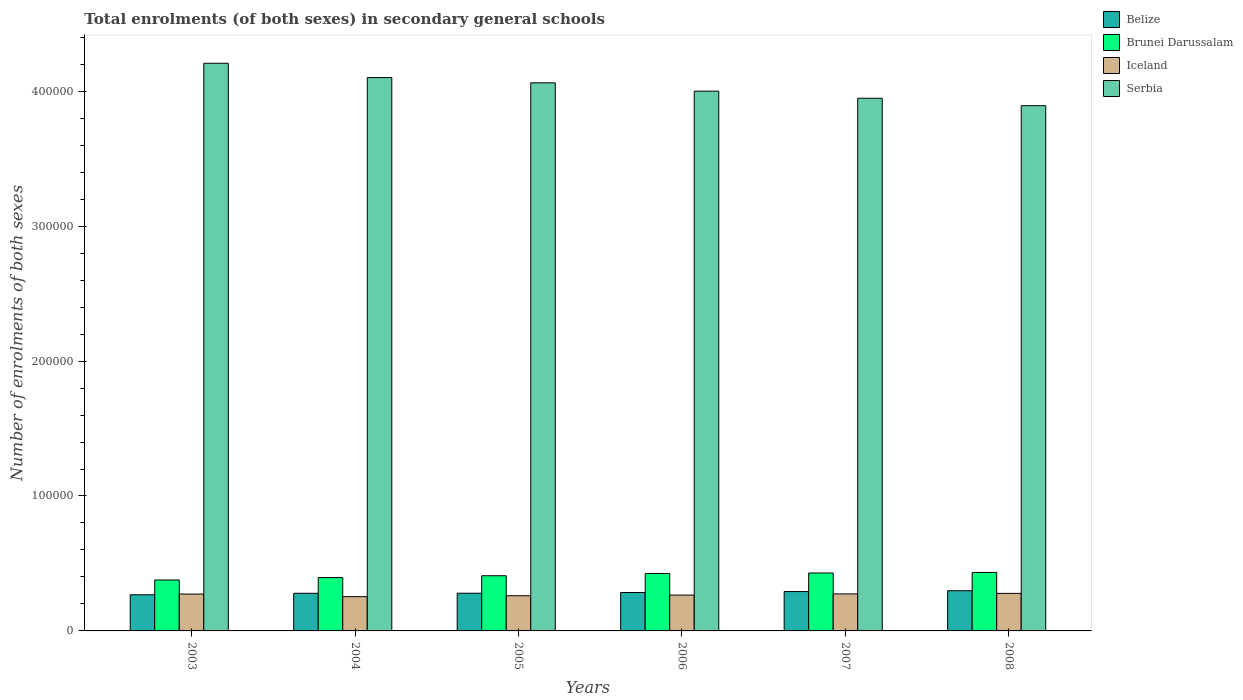How many different coloured bars are there?
Your answer should be compact. 4. How many groups of bars are there?
Your response must be concise. 6. Are the number of bars per tick equal to the number of legend labels?
Provide a succinct answer. Yes. Are the number of bars on each tick of the X-axis equal?
Offer a very short reply. Yes. How many bars are there on the 6th tick from the right?
Provide a short and direct response. 4. What is the label of the 4th group of bars from the left?
Your response must be concise. 2006. In how many cases, is the number of bars for a given year not equal to the number of legend labels?
Provide a short and direct response. 0. What is the number of enrolments in secondary schools in Iceland in 2006?
Give a very brief answer. 2.66e+04. Across all years, what is the maximum number of enrolments in secondary schools in Serbia?
Your response must be concise. 4.21e+05. Across all years, what is the minimum number of enrolments in secondary schools in Iceland?
Your answer should be compact. 2.54e+04. What is the total number of enrolments in secondary schools in Iceland in the graph?
Your response must be concise. 1.61e+05. What is the difference between the number of enrolments in secondary schools in Iceland in 2003 and that in 2005?
Ensure brevity in your answer.  1239. What is the difference between the number of enrolments in secondary schools in Brunei Darussalam in 2008 and the number of enrolments in secondary schools in Belize in 2004?
Offer a very short reply. 1.54e+04. What is the average number of enrolments in secondary schools in Belize per year?
Offer a terse response. 2.83e+04. In the year 2008, what is the difference between the number of enrolments in secondary schools in Serbia and number of enrolments in secondary schools in Belize?
Make the answer very short. 3.59e+05. In how many years, is the number of enrolments in secondary schools in Brunei Darussalam greater than 200000?
Give a very brief answer. 0. What is the ratio of the number of enrolments in secondary schools in Belize in 2005 to that in 2006?
Your answer should be compact. 0.98. Is the difference between the number of enrolments in secondary schools in Serbia in 2005 and 2007 greater than the difference between the number of enrolments in secondary schools in Belize in 2005 and 2007?
Keep it short and to the point. Yes. What is the difference between the highest and the second highest number of enrolments in secondary schools in Belize?
Offer a terse response. 625. What is the difference between the highest and the lowest number of enrolments in secondary schools in Iceland?
Keep it short and to the point. 2421. Is the sum of the number of enrolments in secondary schools in Iceland in 2004 and 2005 greater than the maximum number of enrolments in secondary schools in Serbia across all years?
Your answer should be very brief. No. Is it the case that in every year, the sum of the number of enrolments in secondary schools in Brunei Darussalam and number of enrolments in secondary schools in Serbia is greater than the sum of number of enrolments in secondary schools in Belize and number of enrolments in secondary schools in Iceland?
Keep it short and to the point. Yes. What does the 4th bar from the left in 2008 represents?
Offer a very short reply. Serbia. What does the 4th bar from the right in 2004 represents?
Provide a short and direct response. Belize. How many years are there in the graph?
Your response must be concise. 6. Are the values on the major ticks of Y-axis written in scientific E-notation?
Offer a terse response. No. Where does the legend appear in the graph?
Give a very brief answer. Top right. How many legend labels are there?
Your answer should be compact. 4. How are the legend labels stacked?
Provide a succinct answer. Vertical. What is the title of the graph?
Your response must be concise. Total enrolments (of both sexes) in secondary general schools. Does "Brazil" appear as one of the legend labels in the graph?
Your response must be concise. No. What is the label or title of the X-axis?
Give a very brief answer. Years. What is the label or title of the Y-axis?
Give a very brief answer. Number of enrolments of both sexes. What is the Number of enrolments of both sexes of Belize in 2003?
Provide a succinct answer. 2.68e+04. What is the Number of enrolments of both sexes of Brunei Darussalam in 2003?
Provide a succinct answer. 3.77e+04. What is the Number of enrolments of both sexes in Iceland in 2003?
Offer a very short reply. 2.73e+04. What is the Number of enrolments of both sexes of Serbia in 2003?
Provide a short and direct response. 4.21e+05. What is the Number of enrolments of both sexes in Belize in 2004?
Provide a succinct answer. 2.79e+04. What is the Number of enrolments of both sexes of Brunei Darussalam in 2004?
Make the answer very short. 3.96e+04. What is the Number of enrolments of both sexes of Iceland in 2004?
Give a very brief answer. 2.54e+04. What is the Number of enrolments of both sexes of Serbia in 2004?
Keep it short and to the point. 4.10e+05. What is the Number of enrolments of both sexes of Belize in 2005?
Make the answer very short. 2.79e+04. What is the Number of enrolments of both sexes in Brunei Darussalam in 2005?
Your response must be concise. 4.09e+04. What is the Number of enrolments of both sexes of Iceland in 2005?
Give a very brief answer. 2.61e+04. What is the Number of enrolments of both sexes in Serbia in 2005?
Offer a very short reply. 4.06e+05. What is the Number of enrolments of both sexes in Belize in 2006?
Offer a very short reply. 2.85e+04. What is the Number of enrolments of both sexes in Brunei Darussalam in 2006?
Offer a very short reply. 4.26e+04. What is the Number of enrolments of both sexes in Iceland in 2006?
Your answer should be very brief. 2.66e+04. What is the Number of enrolments of both sexes in Serbia in 2006?
Provide a succinct answer. 4.00e+05. What is the Number of enrolments of both sexes in Belize in 2007?
Ensure brevity in your answer.  2.92e+04. What is the Number of enrolments of both sexes in Brunei Darussalam in 2007?
Your response must be concise. 4.29e+04. What is the Number of enrolments of both sexes in Iceland in 2007?
Offer a terse response. 2.74e+04. What is the Number of enrolments of both sexes of Serbia in 2007?
Your answer should be compact. 3.95e+05. What is the Number of enrolments of both sexes of Belize in 2008?
Your answer should be very brief. 2.98e+04. What is the Number of enrolments of both sexes of Brunei Darussalam in 2008?
Offer a terse response. 4.33e+04. What is the Number of enrolments of both sexes in Iceland in 2008?
Offer a terse response. 2.78e+04. What is the Number of enrolments of both sexes in Serbia in 2008?
Your response must be concise. 3.89e+05. Across all years, what is the maximum Number of enrolments of both sexes in Belize?
Offer a very short reply. 2.98e+04. Across all years, what is the maximum Number of enrolments of both sexes in Brunei Darussalam?
Offer a very short reply. 4.33e+04. Across all years, what is the maximum Number of enrolments of both sexes in Iceland?
Ensure brevity in your answer.  2.78e+04. Across all years, what is the maximum Number of enrolments of both sexes in Serbia?
Offer a terse response. 4.21e+05. Across all years, what is the minimum Number of enrolments of both sexes in Belize?
Your answer should be compact. 2.68e+04. Across all years, what is the minimum Number of enrolments of both sexes of Brunei Darussalam?
Provide a short and direct response. 3.77e+04. Across all years, what is the minimum Number of enrolments of both sexes in Iceland?
Provide a short and direct response. 2.54e+04. Across all years, what is the minimum Number of enrolments of both sexes of Serbia?
Provide a succinct answer. 3.89e+05. What is the total Number of enrolments of both sexes of Belize in the graph?
Provide a succinct answer. 1.70e+05. What is the total Number of enrolments of both sexes in Brunei Darussalam in the graph?
Make the answer very short. 2.47e+05. What is the total Number of enrolments of both sexes of Iceland in the graph?
Ensure brevity in your answer.  1.61e+05. What is the total Number of enrolments of both sexes of Serbia in the graph?
Provide a succinct answer. 2.42e+06. What is the difference between the Number of enrolments of both sexes of Belize in 2003 and that in 2004?
Your answer should be very brief. -1094. What is the difference between the Number of enrolments of both sexes in Brunei Darussalam in 2003 and that in 2004?
Your answer should be very brief. -1810. What is the difference between the Number of enrolments of both sexes of Iceland in 2003 and that in 2004?
Your answer should be compact. 1921. What is the difference between the Number of enrolments of both sexes of Serbia in 2003 and that in 2004?
Give a very brief answer. 1.06e+04. What is the difference between the Number of enrolments of both sexes of Belize in 2003 and that in 2005?
Your answer should be very brief. -1115. What is the difference between the Number of enrolments of both sexes of Brunei Darussalam in 2003 and that in 2005?
Provide a succinct answer. -3147. What is the difference between the Number of enrolments of both sexes in Iceland in 2003 and that in 2005?
Provide a short and direct response. 1239. What is the difference between the Number of enrolments of both sexes in Serbia in 2003 and that in 2005?
Give a very brief answer. 1.45e+04. What is the difference between the Number of enrolments of both sexes in Belize in 2003 and that in 2006?
Provide a succinct answer. -1650. What is the difference between the Number of enrolments of both sexes of Brunei Darussalam in 2003 and that in 2006?
Your response must be concise. -4855. What is the difference between the Number of enrolments of both sexes in Iceland in 2003 and that in 2006?
Your response must be concise. 761. What is the difference between the Number of enrolments of both sexes of Serbia in 2003 and that in 2006?
Give a very brief answer. 2.07e+04. What is the difference between the Number of enrolments of both sexes in Belize in 2003 and that in 2007?
Provide a short and direct response. -2372. What is the difference between the Number of enrolments of both sexes in Brunei Darussalam in 2003 and that in 2007?
Offer a terse response. -5200. What is the difference between the Number of enrolments of both sexes in Iceland in 2003 and that in 2007?
Your answer should be compact. -112. What is the difference between the Number of enrolments of both sexes of Serbia in 2003 and that in 2007?
Offer a very short reply. 2.59e+04. What is the difference between the Number of enrolments of both sexes of Belize in 2003 and that in 2008?
Ensure brevity in your answer.  -2997. What is the difference between the Number of enrolments of both sexes of Brunei Darussalam in 2003 and that in 2008?
Offer a very short reply. -5602. What is the difference between the Number of enrolments of both sexes of Iceland in 2003 and that in 2008?
Keep it short and to the point. -500. What is the difference between the Number of enrolments of both sexes in Serbia in 2003 and that in 2008?
Your response must be concise. 3.14e+04. What is the difference between the Number of enrolments of both sexes in Belize in 2004 and that in 2005?
Ensure brevity in your answer.  -21. What is the difference between the Number of enrolments of both sexes of Brunei Darussalam in 2004 and that in 2005?
Give a very brief answer. -1337. What is the difference between the Number of enrolments of both sexes in Iceland in 2004 and that in 2005?
Keep it short and to the point. -682. What is the difference between the Number of enrolments of both sexes in Serbia in 2004 and that in 2005?
Provide a short and direct response. 3877. What is the difference between the Number of enrolments of both sexes in Belize in 2004 and that in 2006?
Offer a very short reply. -556. What is the difference between the Number of enrolments of both sexes in Brunei Darussalam in 2004 and that in 2006?
Keep it short and to the point. -3045. What is the difference between the Number of enrolments of both sexes in Iceland in 2004 and that in 2006?
Offer a very short reply. -1160. What is the difference between the Number of enrolments of both sexes of Serbia in 2004 and that in 2006?
Give a very brief answer. 1.01e+04. What is the difference between the Number of enrolments of both sexes in Belize in 2004 and that in 2007?
Keep it short and to the point. -1278. What is the difference between the Number of enrolments of both sexes of Brunei Darussalam in 2004 and that in 2007?
Provide a short and direct response. -3390. What is the difference between the Number of enrolments of both sexes in Iceland in 2004 and that in 2007?
Your answer should be compact. -2033. What is the difference between the Number of enrolments of both sexes in Serbia in 2004 and that in 2007?
Keep it short and to the point. 1.53e+04. What is the difference between the Number of enrolments of both sexes of Belize in 2004 and that in 2008?
Provide a succinct answer. -1903. What is the difference between the Number of enrolments of both sexes of Brunei Darussalam in 2004 and that in 2008?
Your response must be concise. -3792. What is the difference between the Number of enrolments of both sexes in Iceland in 2004 and that in 2008?
Make the answer very short. -2421. What is the difference between the Number of enrolments of both sexes of Serbia in 2004 and that in 2008?
Your answer should be compact. 2.08e+04. What is the difference between the Number of enrolments of both sexes of Belize in 2005 and that in 2006?
Give a very brief answer. -535. What is the difference between the Number of enrolments of both sexes of Brunei Darussalam in 2005 and that in 2006?
Make the answer very short. -1708. What is the difference between the Number of enrolments of both sexes in Iceland in 2005 and that in 2006?
Your answer should be very brief. -478. What is the difference between the Number of enrolments of both sexes of Serbia in 2005 and that in 2006?
Your response must be concise. 6180. What is the difference between the Number of enrolments of both sexes in Belize in 2005 and that in 2007?
Your answer should be very brief. -1257. What is the difference between the Number of enrolments of both sexes in Brunei Darussalam in 2005 and that in 2007?
Provide a short and direct response. -2053. What is the difference between the Number of enrolments of both sexes of Iceland in 2005 and that in 2007?
Provide a succinct answer. -1351. What is the difference between the Number of enrolments of both sexes in Serbia in 2005 and that in 2007?
Your answer should be very brief. 1.14e+04. What is the difference between the Number of enrolments of both sexes of Belize in 2005 and that in 2008?
Your answer should be compact. -1882. What is the difference between the Number of enrolments of both sexes of Brunei Darussalam in 2005 and that in 2008?
Your answer should be compact. -2455. What is the difference between the Number of enrolments of both sexes of Iceland in 2005 and that in 2008?
Your answer should be compact. -1739. What is the difference between the Number of enrolments of both sexes in Serbia in 2005 and that in 2008?
Your answer should be very brief. 1.70e+04. What is the difference between the Number of enrolments of both sexes of Belize in 2006 and that in 2007?
Your answer should be very brief. -722. What is the difference between the Number of enrolments of both sexes of Brunei Darussalam in 2006 and that in 2007?
Give a very brief answer. -345. What is the difference between the Number of enrolments of both sexes in Iceland in 2006 and that in 2007?
Provide a short and direct response. -873. What is the difference between the Number of enrolments of both sexes of Serbia in 2006 and that in 2007?
Keep it short and to the point. 5261. What is the difference between the Number of enrolments of both sexes in Belize in 2006 and that in 2008?
Offer a terse response. -1347. What is the difference between the Number of enrolments of both sexes of Brunei Darussalam in 2006 and that in 2008?
Your answer should be compact. -747. What is the difference between the Number of enrolments of both sexes of Iceland in 2006 and that in 2008?
Provide a short and direct response. -1261. What is the difference between the Number of enrolments of both sexes in Serbia in 2006 and that in 2008?
Offer a very short reply. 1.08e+04. What is the difference between the Number of enrolments of both sexes of Belize in 2007 and that in 2008?
Provide a short and direct response. -625. What is the difference between the Number of enrolments of both sexes in Brunei Darussalam in 2007 and that in 2008?
Your answer should be compact. -402. What is the difference between the Number of enrolments of both sexes of Iceland in 2007 and that in 2008?
Keep it short and to the point. -388. What is the difference between the Number of enrolments of both sexes in Serbia in 2007 and that in 2008?
Give a very brief answer. 5512. What is the difference between the Number of enrolments of both sexes in Belize in 2003 and the Number of enrolments of both sexes in Brunei Darussalam in 2004?
Keep it short and to the point. -1.27e+04. What is the difference between the Number of enrolments of both sexes in Belize in 2003 and the Number of enrolments of both sexes in Iceland in 2004?
Keep it short and to the point. 1410. What is the difference between the Number of enrolments of both sexes of Belize in 2003 and the Number of enrolments of both sexes of Serbia in 2004?
Offer a terse response. -3.83e+05. What is the difference between the Number of enrolments of both sexes of Brunei Darussalam in 2003 and the Number of enrolments of both sexes of Iceland in 2004?
Keep it short and to the point. 1.23e+04. What is the difference between the Number of enrolments of both sexes of Brunei Darussalam in 2003 and the Number of enrolments of both sexes of Serbia in 2004?
Your answer should be compact. -3.72e+05. What is the difference between the Number of enrolments of both sexes in Iceland in 2003 and the Number of enrolments of both sexes in Serbia in 2004?
Make the answer very short. -3.83e+05. What is the difference between the Number of enrolments of both sexes in Belize in 2003 and the Number of enrolments of both sexes in Brunei Darussalam in 2005?
Your answer should be compact. -1.41e+04. What is the difference between the Number of enrolments of both sexes in Belize in 2003 and the Number of enrolments of both sexes in Iceland in 2005?
Your response must be concise. 728. What is the difference between the Number of enrolments of both sexes in Belize in 2003 and the Number of enrolments of both sexes in Serbia in 2005?
Offer a terse response. -3.79e+05. What is the difference between the Number of enrolments of both sexes in Brunei Darussalam in 2003 and the Number of enrolments of both sexes in Iceland in 2005?
Offer a terse response. 1.17e+04. What is the difference between the Number of enrolments of both sexes of Brunei Darussalam in 2003 and the Number of enrolments of both sexes of Serbia in 2005?
Provide a short and direct response. -3.68e+05. What is the difference between the Number of enrolments of both sexes in Iceland in 2003 and the Number of enrolments of both sexes in Serbia in 2005?
Your answer should be compact. -3.79e+05. What is the difference between the Number of enrolments of both sexes in Belize in 2003 and the Number of enrolments of both sexes in Brunei Darussalam in 2006?
Your answer should be very brief. -1.58e+04. What is the difference between the Number of enrolments of both sexes of Belize in 2003 and the Number of enrolments of both sexes of Iceland in 2006?
Give a very brief answer. 250. What is the difference between the Number of enrolments of both sexes of Belize in 2003 and the Number of enrolments of both sexes of Serbia in 2006?
Ensure brevity in your answer.  -3.73e+05. What is the difference between the Number of enrolments of both sexes in Brunei Darussalam in 2003 and the Number of enrolments of both sexes in Iceland in 2006?
Offer a terse response. 1.12e+04. What is the difference between the Number of enrolments of both sexes in Brunei Darussalam in 2003 and the Number of enrolments of both sexes in Serbia in 2006?
Ensure brevity in your answer.  -3.62e+05. What is the difference between the Number of enrolments of both sexes in Iceland in 2003 and the Number of enrolments of both sexes in Serbia in 2006?
Keep it short and to the point. -3.73e+05. What is the difference between the Number of enrolments of both sexes of Belize in 2003 and the Number of enrolments of both sexes of Brunei Darussalam in 2007?
Your answer should be compact. -1.61e+04. What is the difference between the Number of enrolments of both sexes in Belize in 2003 and the Number of enrolments of both sexes in Iceland in 2007?
Give a very brief answer. -623. What is the difference between the Number of enrolments of both sexes of Belize in 2003 and the Number of enrolments of both sexes of Serbia in 2007?
Keep it short and to the point. -3.68e+05. What is the difference between the Number of enrolments of both sexes of Brunei Darussalam in 2003 and the Number of enrolments of both sexes of Iceland in 2007?
Your response must be concise. 1.03e+04. What is the difference between the Number of enrolments of both sexes in Brunei Darussalam in 2003 and the Number of enrolments of both sexes in Serbia in 2007?
Your answer should be compact. -3.57e+05. What is the difference between the Number of enrolments of both sexes of Iceland in 2003 and the Number of enrolments of both sexes of Serbia in 2007?
Keep it short and to the point. -3.67e+05. What is the difference between the Number of enrolments of both sexes in Belize in 2003 and the Number of enrolments of both sexes in Brunei Darussalam in 2008?
Provide a short and direct response. -1.65e+04. What is the difference between the Number of enrolments of both sexes of Belize in 2003 and the Number of enrolments of both sexes of Iceland in 2008?
Make the answer very short. -1011. What is the difference between the Number of enrolments of both sexes of Belize in 2003 and the Number of enrolments of both sexes of Serbia in 2008?
Your answer should be compact. -3.62e+05. What is the difference between the Number of enrolments of both sexes of Brunei Darussalam in 2003 and the Number of enrolments of both sexes of Iceland in 2008?
Offer a terse response. 9922. What is the difference between the Number of enrolments of both sexes of Brunei Darussalam in 2003 and the Number of enrolments of both sexes of Serbia in 2008?
Your response must be concise. -3.52e+05. What is the difference between the Number of enrolments of both sexes of Iceland in 2003 and the Number of enrolments of both sexes of Serbia in 2008?
Offer a terse response. -3.62e+05. What is the difference between the Number of enrolments of both sexes in Belize in 2004 and the Number of enrolments of both sexes in Brunei Darussalam in 2005?
Your answer should be compact. -1.30e+04. What is the difference between the Number of enrolments of both sexes of Belize in 2004 and the Number of enrolments of both sexes of Iceland in 2005?
Provide a short and direct response. 1822. What is the difference between the Number of enrolments of both sexes in Belize in 2004 and the Number of enrolments of both sexes in Serbia in 2005?
Provide a short and direct response. -3.78e+05. What is the difference between the Number of enrolments of both sexes of Brunei Darussalam in 2004 and the Number of enrolments of both sexes of Iceland in 2005?
Offer a terse response. 1.35e+04. What is the difference between the Number of enrolments of both sexes in Brunei Darussalam in 2004 and the Number of enrolments of both sexes in Serbia in 2005?
Keep it short and to the point. -3.67e+05. What is the difference between the Number of enrolments of both sexes in Iceland in 2004 and the Number of enrolments of both sexes in Serbia in 2005?
Your answer should be compact. -3.81e+05. What is the difference between the Number of enrolments of both sexes in Belize in 2004 and the Number of enrolments of both sexes in Brunei Darussalam in 2006?
Make the answer very short. -1.47e+04. What is the difference between the Number of enrolments of both sexes in Belize in 2004 and the Number of enrolments of both sexes in Iceland in 2006?
Your answer should be very brief. 1344. What is the difference between the Number of enrolments of both sexes in Belize in 2004 and the Number of enrolments of both sexes in Serbia in 2006?
Provide a short and direct response. -3.72e+05. What is the difference between the Number of enrolments of both sexes in Brunei Darussalam in 2004 and the Number of enrolments of both sexes in Iceland in 2006?
Your answer should be very brief. 1.30e+04. What is the difference between the Number of enrolments of both sexes in Brunei Darussalam in 2004 and the Number of enrolments of both sexes in Serbia in 2006?
Provide a short and direct response. -3.60e+05. What is the difference between the Number of enrolments of both sexes of Iceland in 2004 and the Number of enrolments of both sexes of Serbia in 2006?
Your answer should be compact. -3.75e+05. What is the difference between the Number of enrolments of both sexes in Belize in 2004 and the Number of enrolments of both sexes in Brunei Darussalam in 2007?
Provide a short and direct response. -1.50e+04. What is the difference between the Number of enrolments of both sexes in Belize in 2004 and the Number of enrolments of both sexes in Iceland in 2007?
Your response must be concise. 471. What is the difference between the Number of enrolments of both sexes in Belize in 2004 and the Number of enrolments of both sexes in Serbia in 2007?
Your response must be concise. -3.67e+05. What is the difference between the Number of enrolments of both sexes of Brunei Darussalam in 2004 and the Number of enrolments of both sexes of Iceland in 2007?
Offer a very short reply. 1.21e+04. What is the difference between the Number of enrolments of both sexes of Brunei Darussalam in 2004 and the Number of enrolments of both sexes of Serbia in 2007?
Your response must be concise. -3.55e+05. What is the difference between the Number of enrolments of both sexes in Iceland in 2004 and the Number of enrolments of both sexes in Serbia in 2007?
Offer a very short reply. -3.69e+05. What is the difference between the Number of enrolments of both sexes of Belize in 2004 and the Number of enrolments of both sexes of Brunei Darussalam in 2008?
Your answer should be compact. -1.54e+04. What is the difference between the Number of enrolments of both sexes of Belize in 2004 and the Number of enrolments of both sexes of Iceland in 2008?
Offer a very short reply. 83. What is the difference between the Number of enrolments of both sexes of Belize in 2004 and the Number of enrolments of both sexes of Serbia in 2008?
Offer a terse response. -3.61e+05. What is the difference between the Number of enrolments of both sexes of Brunei Darussalam in 2004 and the Number of enrolments of both sexes of Iceland in 2008?
Provide a succinct answer. 1.17e+04. What is the difference between the Number of enrolments of both sexes in Brunei Darussalam in 2004 and the Number of enrolments of both sexes in Serbia in 2008?
Give a very brief answer. -3.50e+05. What is the difference between the Number of enrolments of both sexes of Iceland in 2004 and the Number of enrolments of both sexes of Serbia in 2008?
Offer a very short reply. -3.64e+05. What is the difference between the Number of enrolments of both sexes of Belize in 2005 and the Number of enrolments of both sexes of Brunei Darussalam in 2006?
Provide a succinct answer. -1.47e+04. What is the difference between the Number of enrolments of both sexes in Belize in 2005 and the Number of enrolments of both sexes in Iceland in 2006?
Keep it short and to the point. 1365. What is the difference between the Number of enrolments of both sexes in Belize in 2005 and the Number of enrolments of both sexes in Serbia in 2006?
Offer a terse response. -3.72e+05. What is the difference between the Number of enrolments of both sexes in Brunei Darussalam in 2005 and the Number of enrolments of both sexes in Iceland in 2006?
Keep it short and to the point. 1.43e+04. What is the difference between the Number of enrolments of both sexes of Brunei Darussalam in 2005 and the Number of enrolments of both sexes of Serbia in 2006?
Your answer should be compact. -3.59e+05. What is the difference between the Number of enrolments of both sexes of Iceland in 2005 and the Number of enrolments of both sexes of Serbia in 2006?
Keep it short and to the point. -3.74e+05. What is the difference between the Number of enrolments of both sexes of Belize in 2005 and the Number of enrolments of both sexes of Brunei Darussalam in 2007?
Your answer should be very brief. -1.50e+04. What is the difference between the Number of enrolments of both sexes of Belize in 2005 and the Number of enrolments of both sexes of Iceland in 2007?
Offer a very short reply. 492. What is the difference between the Number of enrolments of both sexes in Belize in 2005 and the Number of enrolments of both sexes in Serbia in 2007?
Your answer should be compact. -3.67e+05. What is the difference between the Number of enrolments of both sexes in Brunei Darussalam in 2005 and the Number of enrolments of both sexes in Iceland in 2007?
Ensure brevity in your answer.  1.35e+04. What is the difference between the Number of enrolments of both sexes of Brunei Darussalam in 2005 and the Number of enrolments of both sexes of Serbia in 2007?
Your answer should be compact. -3.54e+05. What is the difference between the Number of enrolments of both sexes of Iceland in 2005 and the Number of enrolments of both sexes of Serbia in 2007?
Provide a succinct answer. -3.69e+05. What is the difference between the Number of enrolments of both sexes in Belize in 2005 and the Number of enrolments of both sexes in Brunei Darussalam in 2008?
Your response must be concise. -1.54e+04. What is the difference between the Number of enrolments of both sexes of Belize in 2005 and the Number of enrolments of both sexes of Iceland in 2008?
Make the answer very short. 104. What is the difference between the Number of enrolments of both sexes of Belize in 2005 and the Number of enrolments of both sexes of Serbia in 2008?
Provide a succinct answer. -3.61e+05. What is the difference between the Number of enrolments of both sexes of Brunei Darussalam in 2005 and the Number of enrolments of both sexes of Iceland in 2008?
Keep it short and to the point. 1.31e+04. What is the difference between the Number of enrolments of both sexes of Brunei Darussalam in 2005 and the Number of enrolments of both sexes of Serbia in 2008?
Offer a terse response. -3.48e+05. What is the difference between the Number of enrolments of both sexes in Iceland in 2005 and the Number of enrolments of both sexes in Serbia in 2008?
Keep it short and to the point. -3.63e+05. What is the difference between the Number of enrolments of both sexes in Belize in 2006 and the Number of enrolments of both sexes in Brunei Darussalam in 2007?
Provide a succinct answer. -1.45e+04. What is the difference between the Number of enrolments of both sexes in Belize in 2006 and the Number of enrolments of both sexes in Iceland in 2007?
Provide a short and direct response. 1027. What is the difference between the Number of enrolments of both sexes in Belize in 2006 and the Number of enrolments of both sexes in Serbia in 2007?
Offer a terse response. -3.66e+05. What is the difference between the Number of enrolments of both sexes of Brunei Darussalam in 2006 and the Number of enrolments of both sexes of Iceland in 2007?
Keep it short and to the point. 1.52e+04. What is the difference between the Number of enrolments of both sexes in Brunei Darussalam in 2006 and the Number of enrolments of both sexes in Serbia in 2007?
Make the answer very short. -3.52e+05. What is the difference between the Number of enrolments of both sexes of Iceland in 2006 and the Number of enrolments of both sexes of Serbia in 2007?
Offer a very short reply. -3.68e+05. What is the difference between the Number of enrolments of both sexes in Belize in 2006 and the Number of enrolments of both sexes in Brunei Darussalam in 2008?
Your answer should be very brief. -1.49e+04. What is the difference between the Number of enrolments of both sexes of Belize in 2006 and the Number of enrolments of both sexes of Iceland in 2008?
Your answer should be very brief. 639. What is the difference between the Number of enrolments of both sexes in Belize in 2006 and the Number of enrolments of both sexes in Serbia in 2008?
Give a very brief answer. -3.61e+05. What is the difference between the Number of enrolments of both sexes in Brunei Darussalam in 2006 and the Number of enrolments of both sexes in Iceland in 2008?
Offer a very short reply. 1.48e+04. What is the difference between the Number of enrolments of both sexes in Brunei Darussalam in 2006 and the Number of enrolments of both sexes in Serbia in 2008?
Offer a terse response. -3.47e+05. What is the difference between the Number of enrolments of both sexes of Iceland in 2006 and the Number of enrolments of both sexes of Serbia in 2008?
Give a very brief answer. -3.63e+05. What is the difference between the Number of enrolments of both sexes in Belize in 2007 and the Number of enrolments of both sexes in Brunei Darussalam in 2008?
Ensure brevity in your answer.  -1.42e+04. What is the difference between the Number of enrolments of both sexes in Belize in 2007 and the Number of enrolments of both sexes in Iceland in 2008?
Your answer should be compact. 1361. What is the difference between the Number of enrolments of both sexes in Belize in 2007 and the Number of enrolments of both sexes in Serbia in 2008?
Your answer should be very brief. -3.60e+05. What is the difference between the Number of enrolments of both sexes in Brunei Darussalam in 2007 and the Number of enrolments of both sexes in Iceland in 2008?
Keep it short and to the point. 1.51e+04. What is the difference between the Number of enrolments of both sexes in Brunei Darussalam in 2007 and the Number of enrolments of both sexes in Serbia in 2008?
Offer a terse response. -3.46e+05. What is the difference between the Number of enrolments of both sexes in Iceland in 2007 and the Number of enrolments of both sexes in Serbia in 2008?
Provide a succinct answer. -3.62e+05. What is the average Number of enrolments of both sexes of Belize per year?
Your response must be concise. 2.83e+04. What is the average Number of enrolments of both sexes of Brunei Darussalam per year?
Your answer should be compact. 4.12e+04. What is the average Number of enrolments of both sexes of Iceland per year?
Ensure brevity in your answer.  2.68e+04. What is the average Number of enrolments of both sexes in Serbia per year?
Provide a succinct answer. 4.04e+05. In the year 2003, what is the difference between the Number of enrolments of both sexes of Belize and Number of enrolments of both sexes of Brunei Darussalam?
Your response must be concise. -1.09e+04. In the year 2003, what is the difference between the Number of enrolments of both sexes of Belize and Number of enrolments of both sexes of Iceland?
Ensure brevity in your answer.  -511. In the year 2003, what is the difference between the Number of enrolments of both sexes in Belize and Number of enrolments of both sexes in Serbia?
Provide a succinct answer. -3.94e+05. In the year 2003, what is the difference between the Number of enrolments of both sexes in Brunei Darussalam and Number of enrolments of both sexes in Iceland?
Keep it short and to the point. 1.04e+04. In the year 2003, what is the difference between the Number of enrolments of both sexes in Brunei Darussalam and Number of enrolments of both sexes in Serbia?
Your answer should be compact. -3.83e+05. In the year 2003, what is the difference between the Number of enrolments of both sexes in Iceland and Number of enrolments of both sexes in Serbia?
Your answer should be compact. -3.93e+05. In the year 2004, what is the difference between the Number of enrolments of both sexes of Belize and Number of enrolments of both sexes of Brunei Darussalam?
Keep it short and to the point. -1.16e+04. In the year 2004, what is the difference between the Number of enrolments of both sexes in Belize and Number of enrolments of both sexes in Iceland?
Give a very brief answer. 2504. In the year 2004, what is the difference between the Number of enrolments of both sexes of Belize and Number of enrolments of both sexes of Serbia?
Offer a very short reply. -3.82e+05. In the year 2004, what is the difference between the Number of enrolments of both sexes in Brunei Darussalam and Number of enrolments of both sexes in Iceland?
Provide a short and direct response. 1.42e+04. In the year 2004, what is the difference between the Number of enrolments of both sexes in Brunei Darussalam and Number of enrolments of both sexes in Serbia?
Your response must be concise. -3.71e+05. In the year 2004, what is the difference between the Number of enrolments of both sexes of Iceland and Number of enrolments of both sexes of Serbia?
Provide a short and direct response. -3.85e+05. In the year 2005, what is the difference between the Number of enrolments of both sexes of Belize and Number of enrolments of both sexes of Brunei Darussalam?
Offer a very short reply. -1.30e+04. In the year 2005, what is the difference between the Number of enrolments of both sexes in Belize and Number of enrolments of both sexes in Iceland?
Ensure brevity in your answer.  1843. In the year 2005, what is the difference between the Number of enrolments of both sexes in Belize and Number of enrolments of both sexes in Serbia?
Your answer should be compact. -3.78e+05. In the year 2005, what is the difference between the Number of enrolments of both sexes in Brunei Darussalam and Number of enrolments of both sexes in Iceland?
Provide a short and direct response. 1.48e+04. In the year 2005, what is the difference between the Number of enrolments of both sexes of Brunei Darussalam and Number of enrolments of both sexes of Serbia?
Provide a short and direct response. -3.65e+05. In the year 2005, what is the difference between the Number of enrolments of both sexes in Iceland and Number of enrolments of both sexes in Serbia?
Keep it short and to the point. -3.80e+05. In the year 2006, what is the difference between the Number of enrolments of both sexes in Belize and Number of enrolments of both sexes in Brunei Darussalam?
Your response must be concise. -1.41e+04. In the year 2006, what is the difference between the Number of enrolments of both sexes of Belize and Number of enrolments of both sexes of Iceland?
Offer a terse response. 1900. In the year 2006, what is the difference between the Number of enrolments of both sexes in Belize and Number of enrolments of both sexes in Serbia?
Ensure brevity in your answer.  -3.72e+05. In the year 2006, what is the difference between the Number of enrolments of both sexes of Brunei Darussalam and Number of enrolments of both sexes of Iceland?
Make the answer very short. 1.60e+04. In the year 2006, what is the difference between the Number of enrolments of both sexes in Brunei Darussalam and Number of enrolments of both sexes in Serbia?
Offer a terse response. -3.57e+05. In the year 2006, what is the difference between the Number of enrolments of both sexes in Iceland and Number of enrolments of both sexes in Serbia?
Make the answer very short. -3.73e+05. In the year 2007, what is the difference between the Number of enrolments of both sexes of Belize and Number of enrolments of both sexes of Brunei Darussalam?
Your answer should be compact. -1.38e+04. In the year 2007, what is the difference between the Number of enrolments of both sexes in Belize and Number of enrolments of both sexes in Iceland?
Keep it short and to the point. 1749. In the year 2007, what is the difference between the Number of enrolments of both sexes in Belize and Number of enrolments of both sexes in Serbia?
Offer a very short reply. -3.66e+05. In the year 2007, what is the difference between the Number of enrolments of both sexes of Brunei Darussalam and Number of enrolments of both sexes of Iceland?
Your answer should be compact. 1.55e+04. In the year 2007, what is the difference between the Number of enrolments of both sexes in Brunei Darussalam and Number of enrolments of both sexes in Serbia?
Your response must be concise. -3.52e+05. In the year 2007, what is the difference between the Number of enrolments of both sexes of Iceland and Number of enrolments of both sexes of Serbia?
Provide a succinct answer. -3.67e+05. In the year 2008, what is the difference between the Number of enrolments of both sexes of Belize and Number of enrolments of both sexes of Brunei Darussalam?
Make the answer very short. -1.35e+04. In the year 2008, what is the difference between the Number of enrolments of both sexes of Belize and Number of enrolments of both sexes of Iceland?
Your answer should be compact. 1986. In the year 2008, what is the difference between the Number of enrolments of both sexes in Belize and Number of enrolments of both sexes in Serbia?
Keep it short and to the point. -3.59e+05. In the year 2008, what is the difference between the Number of enrolments of both sexes of Brunei Darussalam and Number of enrolments of both sexes of Iceland?
Your response must be concise. 1.55e+04. In the year 2008, what is the difference between the Number of enrolments of both sexes in Brunei Darussalam and Number of enrolments of both sexes in Serbia?
Offer a terse response. -3.46e+05. In the year 2008, what is the difference between the Number of enrolments of both sexes of Iceland and Number of enrolments of both sexes of Serbia?
Ensure brevity in your answer.  -3.61e+05. What is the ratio of the Number of enrolments of both sexes of Belize in 2003 to that in 2004?
Your answer should be very brief. 0.96. What is the ratio of the Number of enrolments of both sexes of Brunei Darussalam in 2003 to that in 2004?
Your response must be concise. 0.95. What is the ratio of the Number of enrolments of both sexes of Iceland in 2003 to that in 2004?
Keep it short and to the point. 1.08. What is the ratio of the Number of enrolments of both sexes in Serbia in 2003 to that in 2004?
Provide a short and direct response. 1.03. What is the ratio of the Number of enrolments of both sexes of Belize in 2003 to that in 2005?
Your answer should be compact. 0.96. What is the ratio of the Number of enrolments of both sexes in Brunei Darussalam in 2003 to that in 2005?
Provide a short and direct response. 0.92. What is the ratio of the Number of enrolments of both sexes in Iceland in 2003 to that in 2005?
Your answer should be very brief. 1.05. What is the ratio of the Number of enrolments of both sexes in Serbia in 2003 to that in 2005?
Keep it short and to the point. 1.04. What is the ratio of the Number of enrolments of both sexes in Belize in 2003 to that in 2006?
Provide a succinct answer. 0.94. What is the ratio of the Number of enrolments of both sexes in Brunei Darussalam in 2003 to that in 2006?
Your answer should be compact. 0.89. What is the ratio of the Number of enrolments of both sexes in Iceland in 2003 to that in 2006?
Offer a terse response. 1.03. What is the ratio of the Number of enrolments of both sexes of Serbia in 2003 to that in 2006?
Provide a short and direct response. 1.05. What is the ratio of the Number of enrolments of both sexes in Belize in 2003 to that in 2007?
Give a very brief answer. 0.92. What is the ratio of the Number of enrolments of both sexes in Brunei Darussalam in 2003 to that in 2007?
Offer a terse response. 0.88. What is the ratio of the Number of enrolments of both sexes in Serbia in 2003 to that in 2007?
Offer a terse response. 1.07. What is the ratio of the Number of enrolments of both sexes in Belize in 2003 to that in 2008?
Make the answer very short. 0.9. What is the ratio of the Number of enrolments of both sexes in Brunei Darussalam in 2003 to that in 2008?
Your response must be concise. 0.87. What is the ratio of the Number of enrolments of both sexes of Iceland in 2003 to that in 2008?
Ensure brevity in your answer.  0.98. What is the ratio of the Number of enrolments of both sexes of Serbia in 2003 to that in 2008?
Make the answer very short. 1.08. What is the ratio of the Number of enrolments of both sexes in Brunei Darussalam in 2004 to that in 2005?
Keep it short and to the point. 0.97. What is the ratio of the Number of enrolments of both sexes of Iceland in 2004 to that in 2005?
Your response must be concise. 0.97. What is the ratio of the Number of enrolments of both sexes of Serbia in 2004 to that in 2005?
Provide a short and direct response. 1.01. What is the ratio of the Number of enrolments of both sexes of Belize in 2004 to that in 2006?
Offer a very short reply. 0.98. What is the ratio of the Number of enrolments of both sexes of Brunei Darussalam in 2004 to that in 2006?
Offer a very short reply. 0.93. What is the ratio of the Number of enrolments of both sexes in Iceland in 2004 to that in 2006?
Keep it short and to the point. 0.96. What is the ratio of the Number of enrolments of both sexes in Serbia in 2004 to that in 2006?
Give a very brief answer. 1.03. What is the ratio of the Number of enrolments of both sexes in Belize in 2004 to that in 2007?
Your response must be concise. 0.96. What is the ratio of the Number of enrolments of both sexes of Brunei Darussalam in 2004 to that in 2007?
Your answer should be very brief. 0.92. What is the ratio of the Number of enrolments of both sexes of Iceland in 2004 to that in 2007?
Keep it short and to the point. 0.93. What is the ratio of the Number of enrolments of both sexes of Serbia in 2004 to that in 2007?
Your answer should be very brief. 1.04. What is the ratio of the Number of enrolments of both sexes of Belize in 2004 to that in 2008?
Keep it short and to the point. 0.94. What is the ratio of the Number of enrolments of both sexes of Brunei Darussalam in 2004 to that in 2008?
Provide a short and direct response. 0.91. What is the ratio of the Number of enrolments of both sexes in Iceland in 2004 to that in 2008?
Your answer should be very brief. 0.91. What is the ratio of the Number of enrolments of both sexes in Serbia in 2004 to that in 2008?
Keep it short and to the point. 1.05. What is the ratio of the Number of enrolments of both sexes in Belize in 2005 to that in 2006?
Your answer should be very brief. 0.98. What is the ratio of the Number of enrolments of both sexes in Brunei Darussalam in 2005 to that in 2006?
Make the answer very short. 0.96. What is the ratio of the Number of enrolments of both sexes in Serbia in 2005 to that in 2006?
Your answer should be compact. 1.02. What is the ratio of the Number of enrolments of both sexes of Belize in 2005 to that in 2007?
Offer a very short reply. 0.96. What is the ratio of the Number of enrolments of both sexes of Brunei Darussalam in 2005 to that in 2007?
Your response must be concise. 0.95. What is the ratio of the Number of enrolments of both sexes in Iceland in 2005 to that in 2007?
Your answer should be very brief. 0.95. What is the ratio of the Number of enrolments of both sexes of Serbia in 2005 to that in 2007?
Ensure brevity in your answer.  1.03. What is the ratio of the Number of enrolments of both sexes of Belize in 2005 to that in 2008?
Offer a terse response. 0.94. What is the ratio of the Number of enrolments of both sexes in Brunei Darussalam in 2005 to that in 2008?
Offer a very short reply. 0.94. What is the ratio of the Number of enrolments of both sexes in Serbia in 2005 to that in 2008?
Offer a very short reply. 1.04. What is the ratio of the Number of enrolments of both sexes of Belize in 2006 to that in 2007?
Keep it short and to the point. 0.98. What is the ratio of the Number of enrolments of both sexes in Brunei Darussalam in 2006 to that in 2007?
Give a very brief answer. 0.99. What is the ratio of the Number of enrolments of both sexes of Iceland in 2006 to that in 2007?
Offer a terse response. 0.97. What is the ratio of the Number of enrolments of both sexes in Serbia in 2006 to that in 2007?
Give a very brief answer. 1.01. What is the ratio of the Number of enrolments of both sexes of Belize in 2006 to that in 2008?
Your answer should be very brief. 0.95. What is the ratio of the Number of enrolments of both sexes in Brunei Darussalam in 2006 to that in 2008?
Provide a short and direct response. 0.98. What is the ratio of the Number of enrolments of both sexes of Iceland in 2006 to that in 2008?
Your response must be concise. 0.95. What is the ratio of the Number of enrolments of both sexes in Serbia in 2006 to that in 2008?
Provide a short and direct response. 1.03. What is the ratio of the Number of enrolments of both sexes of Iceland in 2007 to that in 2008?
Provide a short and direct response. 0.99. What is the ratio of the Number of enrolments of both sexes of Serbia in 2007 to that in 2008?
Your response must be concise. 1.01. What is the difference between the highest and the second highest Number of enrolments of both sexes of Belize?
Provide a short and direct response. 625. What is the difference between the highest and the second highest Number of enrolments of both sexes of Brunei Darussalam?
Your response must be concise. 402. What is the difference between the highest and the second highest Number of enrolments of both sexes in Iceland?
Offer a very short reply. 388. What is the difference between the highest and the second highest Number of enrolments of both sexes in Serbia?
Provide a short and direct response. 1.06e+04. What is the difference between the highest and the lowest Number of enrolments of both sexes of Belize?
Offer a very short reply. 2997. What is the difference between the highest and the lowest Number of enrolments of both sexes of Brunei Darussalam?
Ensure brevity in your answer.  5602. What is the difference between the highest and the lowest Number of enrolments of both sexes of Iceland?
Provide a short and direct response. 2421. What is the difference between the highest and the lowest Number of enrolments of both sexes of Serbia?
Ensure brevity in your answer.  3.14e+04. 